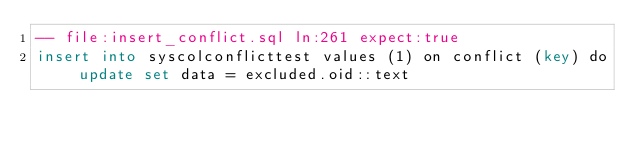Convert code to text. <code><loc_0><loc_0><loc_500><loc_500><_SQL_>-- file:insert_conflict.sql ln:261 expect:true
insert into syscolconflicttest values (1) on conflict (key) do update set data = excluded.oid::text
</code> 